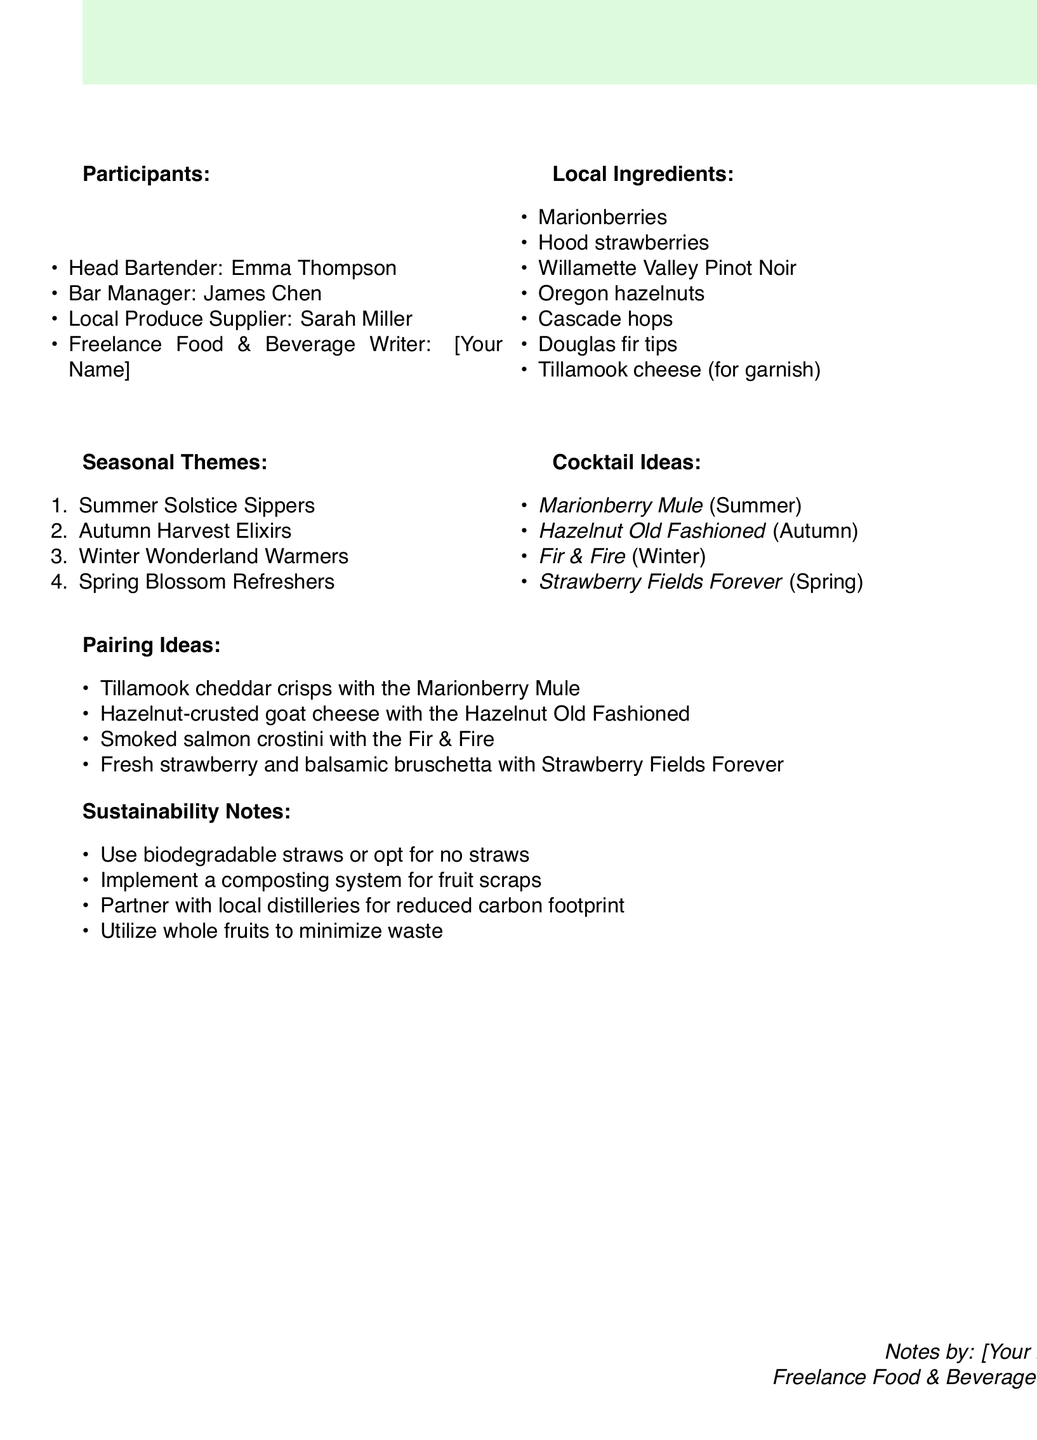What is the title of the brainstorming session? The title is listed at the beginning of the document under "sessionTitle."
Answer: Seasonal Cocktails with Local Ingredients Who is the local produce supplier present at the session? The document lists participants, including their roles.
Answer: Sarah Miller What is one of the local ingredients used in the cocktail recipes? Local ingredients are provided in a specific section of the document.
Answer: Marionberries Which cocktail is inspired by Douglas fir tips? The document specifies the cocktails and their key ingredients, including seasonal themes.
Answer: Fir & Fire How many seasonal themes are discussed? The document lists seasonal themes under "seasonalThemes."
Answer: Four What pairing is suggested with the Marionberry Mule? Pairing ideas are outlined in a specific section of the document related to each cocktail.
Answer: Tillamook cheddar crisps What sustainability note suggests not using straws? The sustainability notes section provides various practices for reduction of waste.
Answer: Use biodegradable straws or opt for no straws Which season is the Hazelnut Old Fashioned associated with? The cocktail ideas are categorized by seasons listed in the document.
Answer: Autumn 